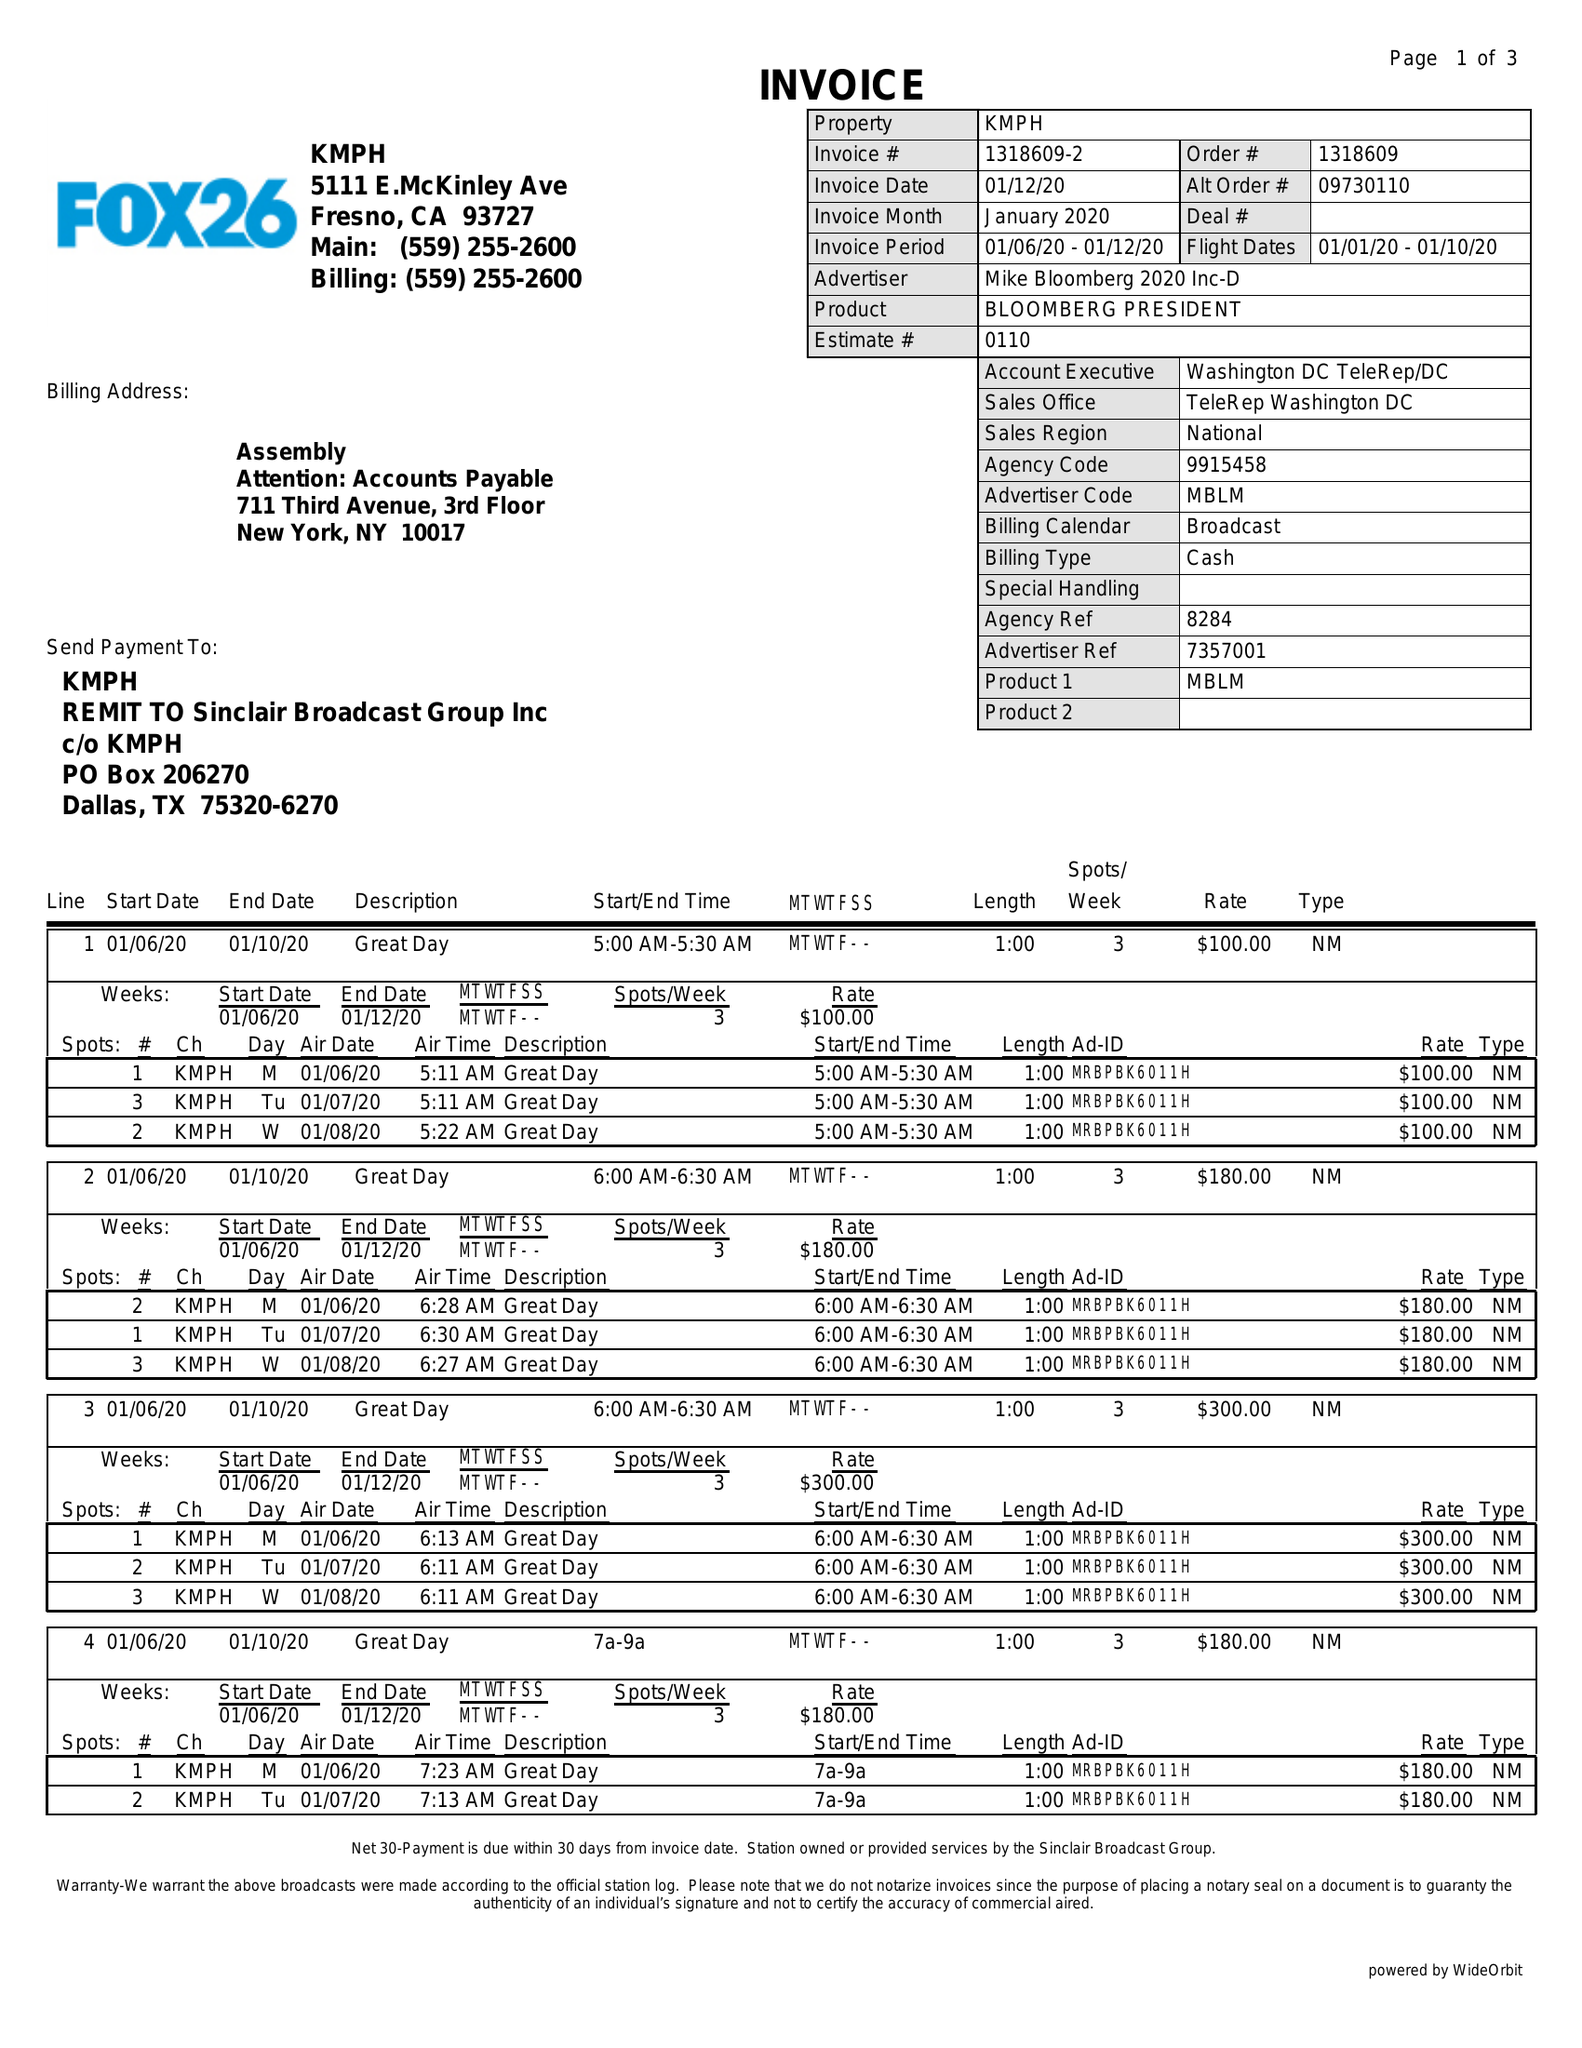What is the value for the gross_amount?
Answer the question using a single word or phrase. 12490.00 